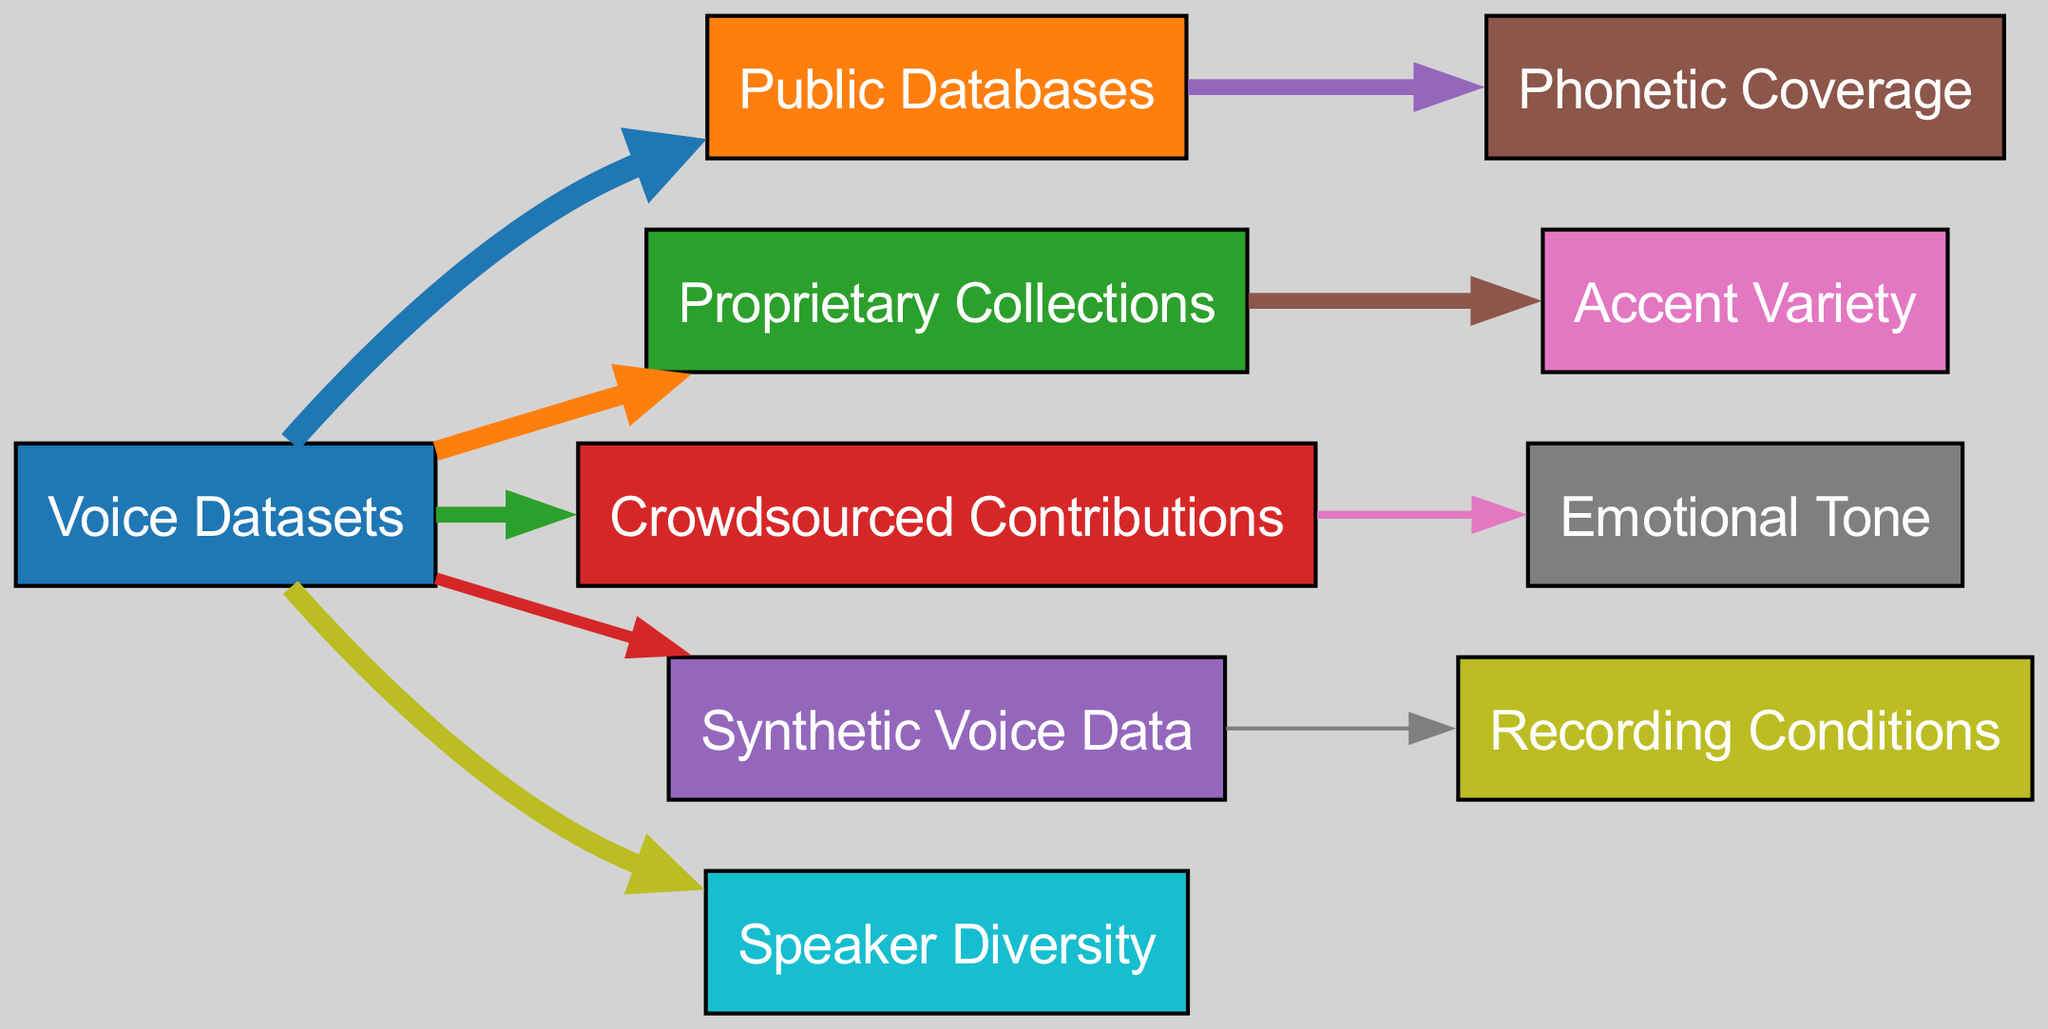What is the value of Crowdsourced Contributions? The diagram shows that the Crowdsourced Contributions node has a value of 20, indicating its contribution level to the Voice Datasets.
Answer: 20 Which node contributes the most to Speaker Diversity? By examining the links from the Voice Datasets, it can be seen that the value directed towards Speaker Diversity is 25, sourced primarily from the voice datasets.
Answer: 25 How many nodes are in the diagram? Counting the nodes listed in the data, there are a total of 10 distinct nodes shown in the Sankey Diagram, representing various sources and attributes related to voice datasets.
Answer: 10 What type of data contributes to Phonetic Coverage? The link from Public Databases indicates that this source primarily contributes to Phonetic Coverage as it has a direct edge to it with a value of 20.
Answer: Public Databases Which source has the least contribution and what is its value? Looking at the values of all links leading from the Voice Datasets, the Synthetic Voice Data has the least contribution at a value of 15, which is lower than all other sources.
Answer: 15 What is the relationship between Proprietary Collections and Accent Variety? The diagram illustrates a direct connection where Proprietary Collections directly contributes to Accent Variety, with a value of 20 linking the two.
Answer: 20 What percentage of the total dataset contribution does Public Databases represent? The total contributions from all sources can be summed to 100 (30+25+20+15). Public Databases contributes 30, thus it represents 30% of the total voice dataset contribution.
Answer: 30% Which source has no direct connection to Emotional Tone? By reviewing the links from each dataset source, it is clear that the Synthetic Voice Data does not have a direct connection to Emotional Tone based on the provided edges in the diagram.
Answer: Synthetic Voice Data Which characteristics are influenced by Crowdsourced Contributions? The diagram connects Crowdsourced Contributions to Emotional Tone, with a value of 10, indicating that this source directly impacts the emotional tone characteristic of the voice datasets.
Answer: Emotional Tone 